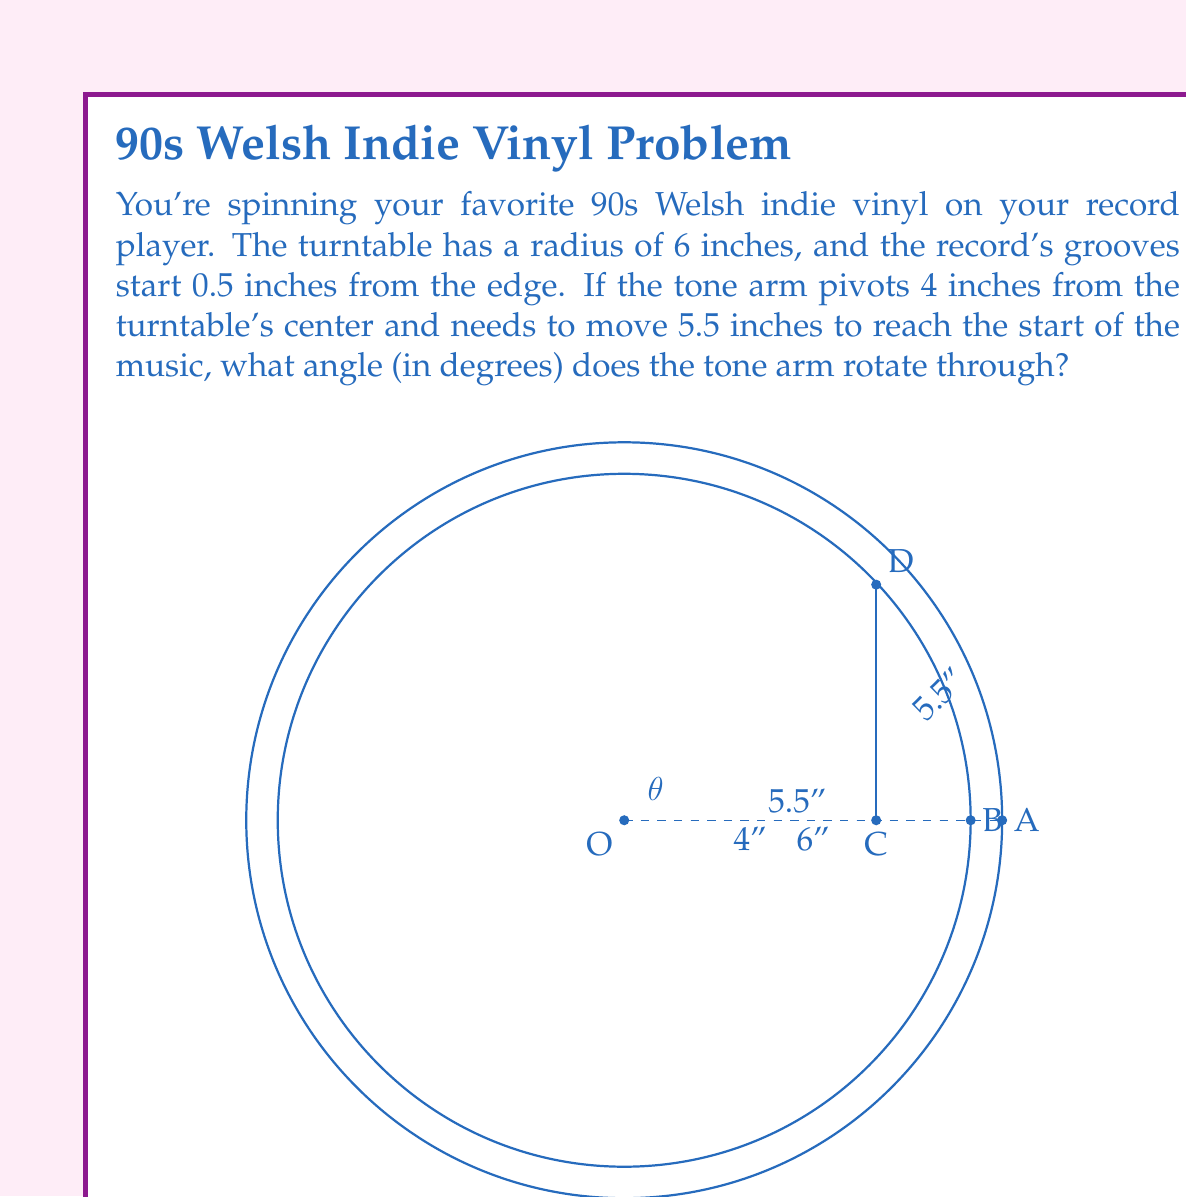Solve this math problem. Let's approach this step-by-step:

1) First, we need to identify the right triangle formed by the tone arm's movement. The hypotenuse of this triangle is 5.5 inches (the distance the arm moves), and one side is 4 inches (the distance from the pivot to the turntable center).

2) We can find the angle $\theta$ using the inverse cosine function (arccos or $\cos^{-1}$):

   $$\cos \theta = \frac{\text{adjacent}}{\text{hypotenuse}} = \frac{4}{5.5}$$

3) Therefore:
   $$\theta = \cos^{-1}\left(\frac{4}{5.5}\right)$$

4) Using a calculator or computer:
   $$\theta \approx 43.95^\circ$$

5) However, this is not the final answer. This angle represents the angle between the tone arm and the line from the pivot to the turntable center. We need the angle from the starting position (when the arm is at the edge of the record) to this position.

6) The total angle swept by the arm is the difference between 90° (the starting position, perpendicular to the radius) and the angle we calculated:

   $$\text{Total angle} = 90^\circ - 43.95^\circ = 46.05^\circ$$

7) Rounding to the nearest degree gives us 46°.
Answer: 46° 